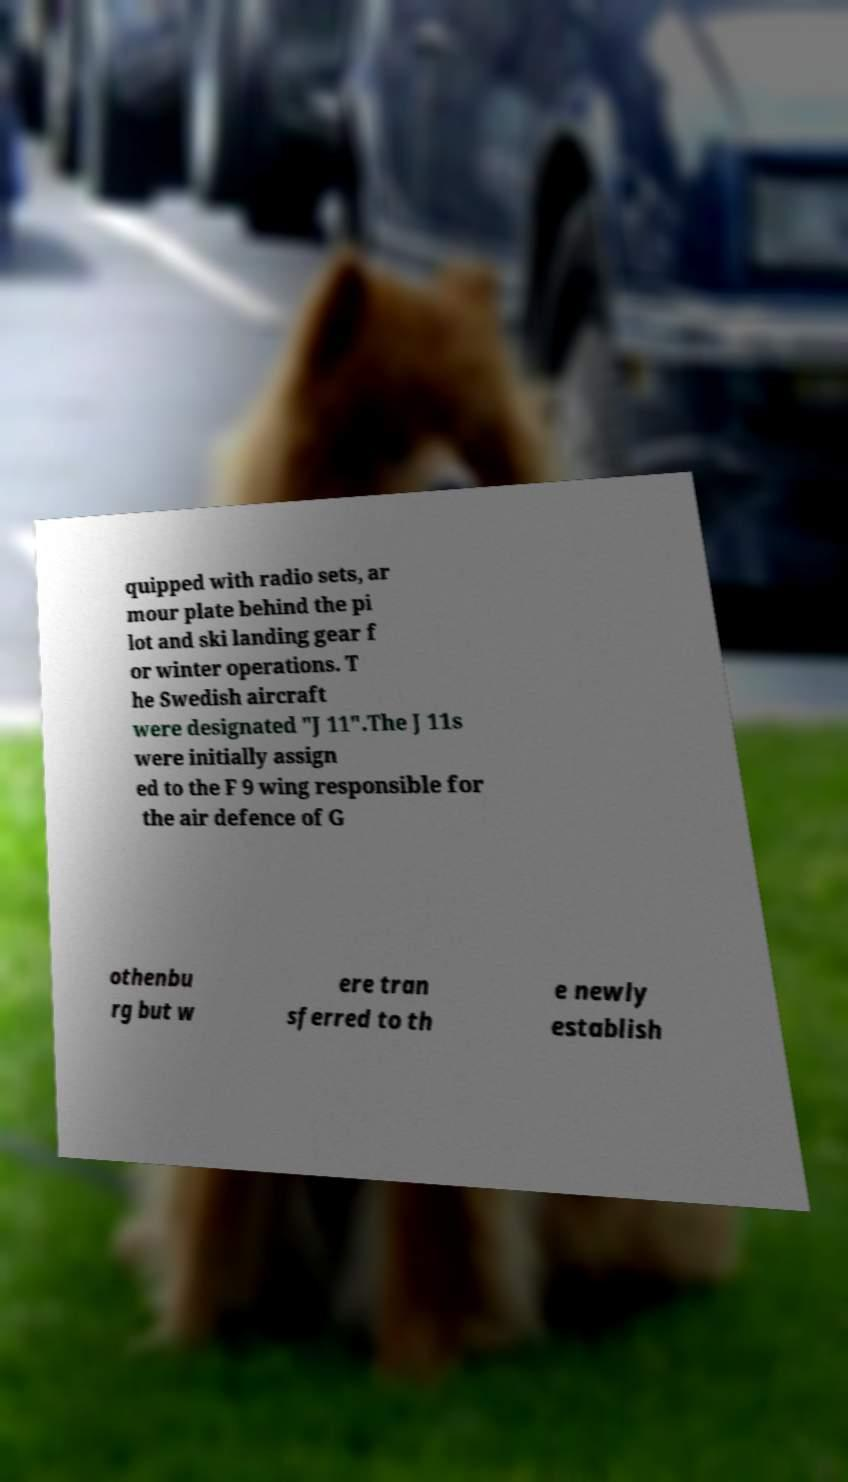I need the written content from this picture converted into text. Can you do that? quipped with radio sets, ar mour plate behind the pi lot and ski landing gear f or winter operations. T he Swedish aircraft were designated "J 11".The J 11s were initially assign ed to the F 9 wing responsible for the air defence of G othenbu rg but w ere tran sferred to th e newly establish 